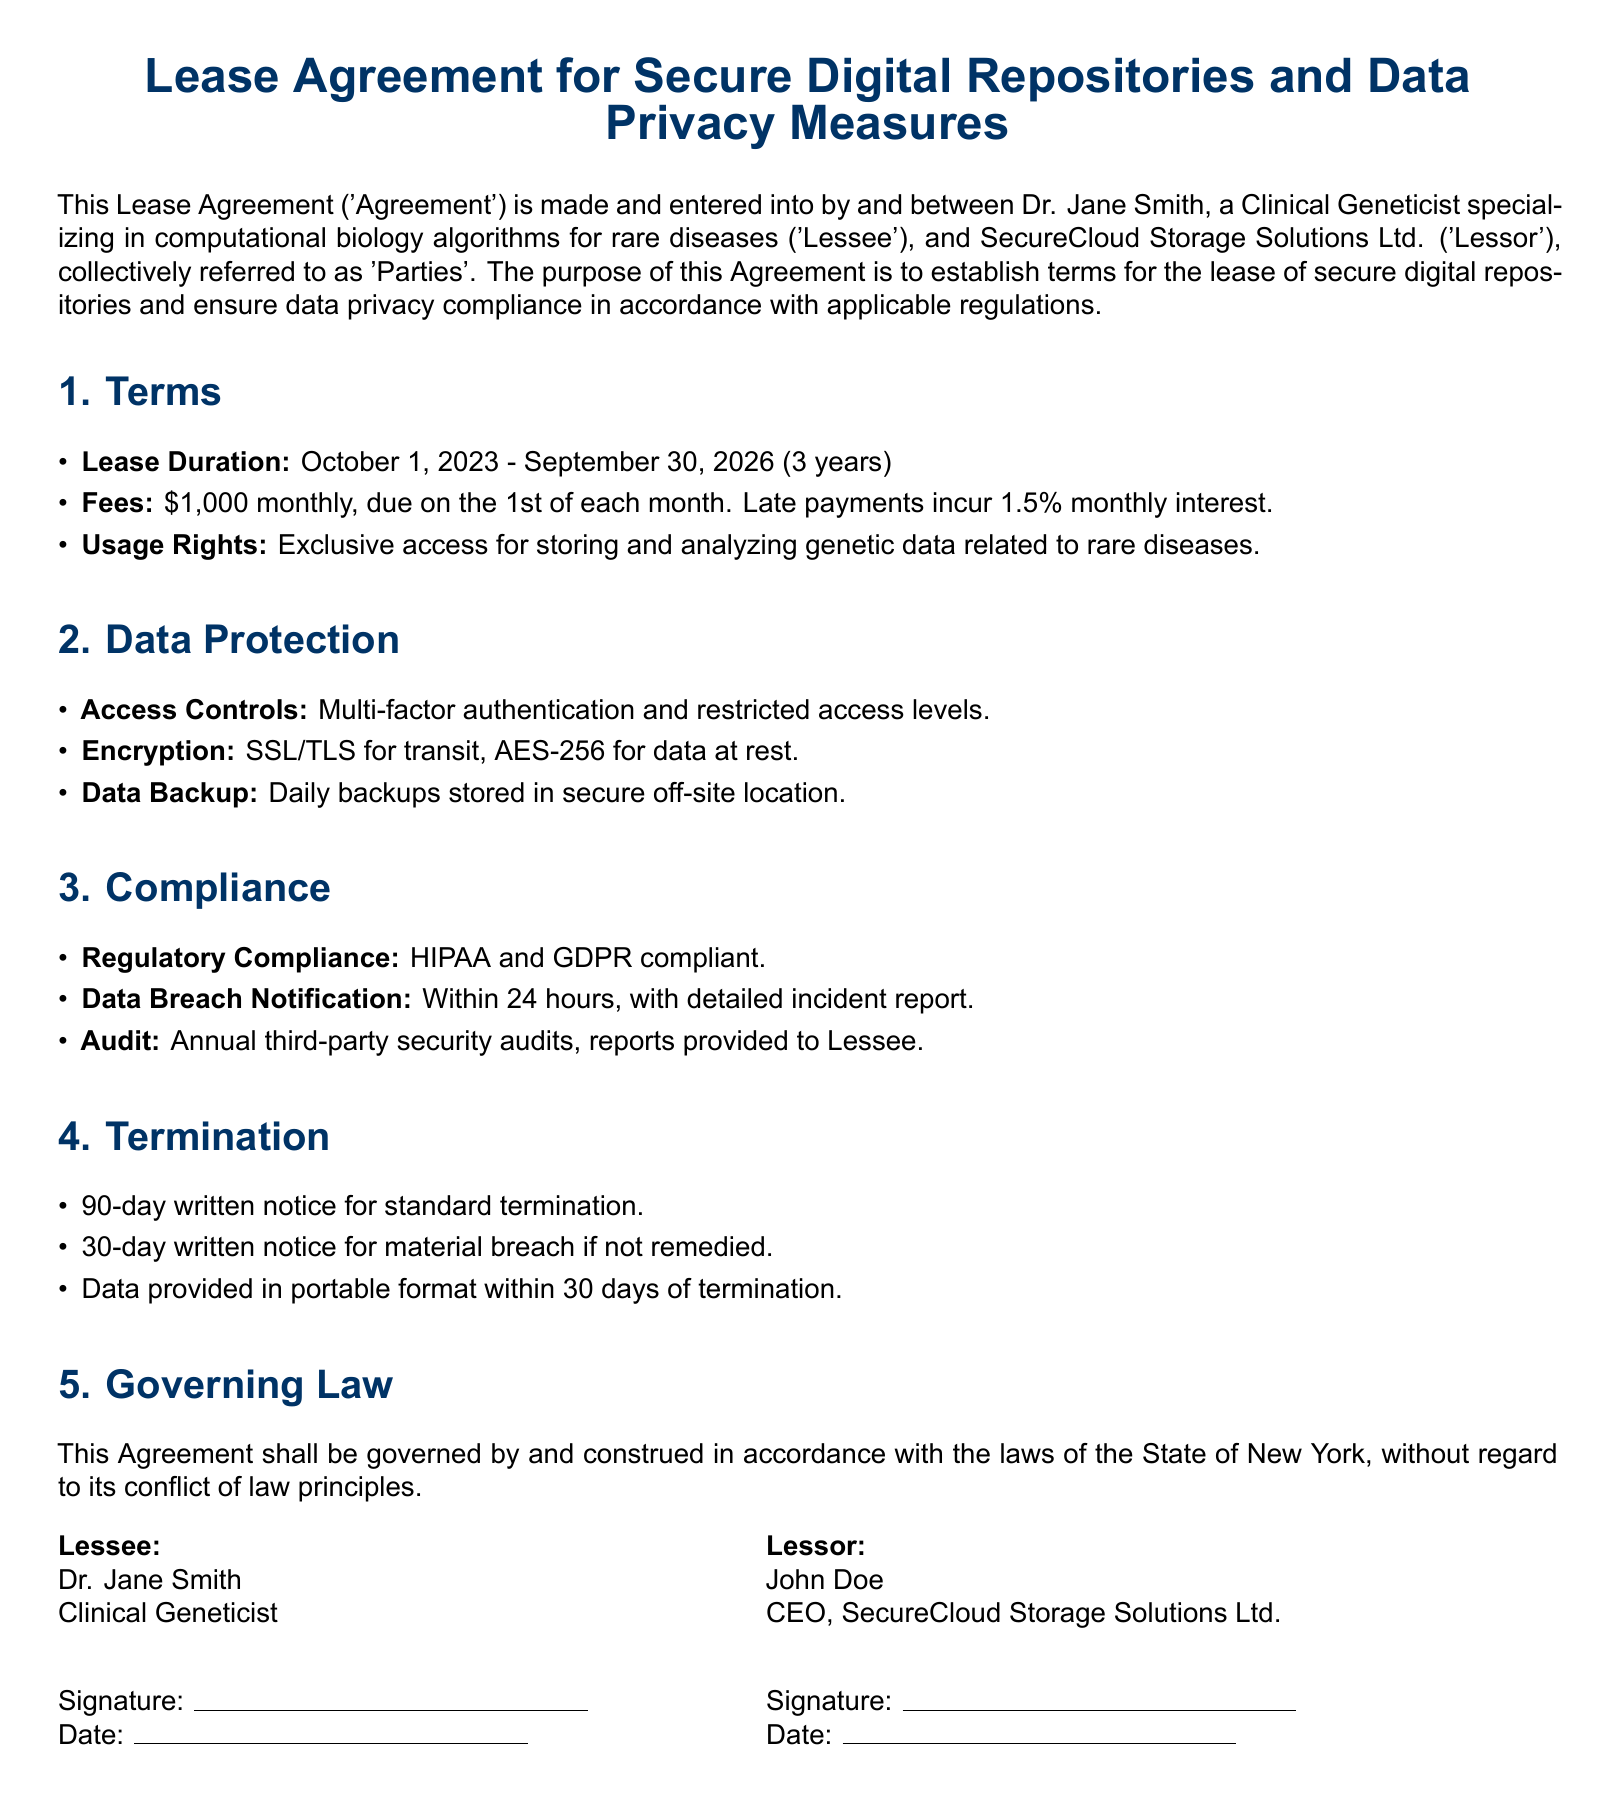What is the lease duration? The lease duration is specified in the Terms section of the document as October 1, 2023 - September 30, 2026.
Answer: October 1, 2023 - September 30, 2026 What is the monthly fee for the lease? The monthly fee is mentioned under the Fees section, indicating it is set at one thousand dollars.
Answer: $1,000 What security measures are implemented for data protection? The document outlines specific measures such as multi-factor authentication, SSL/TLS encryption for transit, and AES-256 encryption for data at rest in the Data Protection section.
Answer: Multi-factor authentication, SSL/TLS, AES-256 What compliance regulations does the agreement adhere to? The Compliance section includes the requirements for HIPAA and GDPR compliance.
Answer: HIPAA and GDPR What is the notice period for standard termination? The standard termination notice period is outlined in the Termination section of the document, specifying a period of ninety days.
Answer: 90 days How quickly must data breach notifications be made? The agreement states that notifications of data breaches must occur within twenty-four hours as part of the Compliance section.
Answer: 24 hours Who is the CEO of the Lessor? The document identifies John Doe as the CEO of SecureCloud Storage Solutions Ltd. in the signatory section.
Answer: John Doe What format will the data be provided in upon termination? The Termination section specifies that data must be provided in a portable format within thirty days of termination.
Answer: Portable format In which state is the agreement governed? The Governing Law section indicates that the agreement is governed by the laws of the State of New York.
Answer: New York 